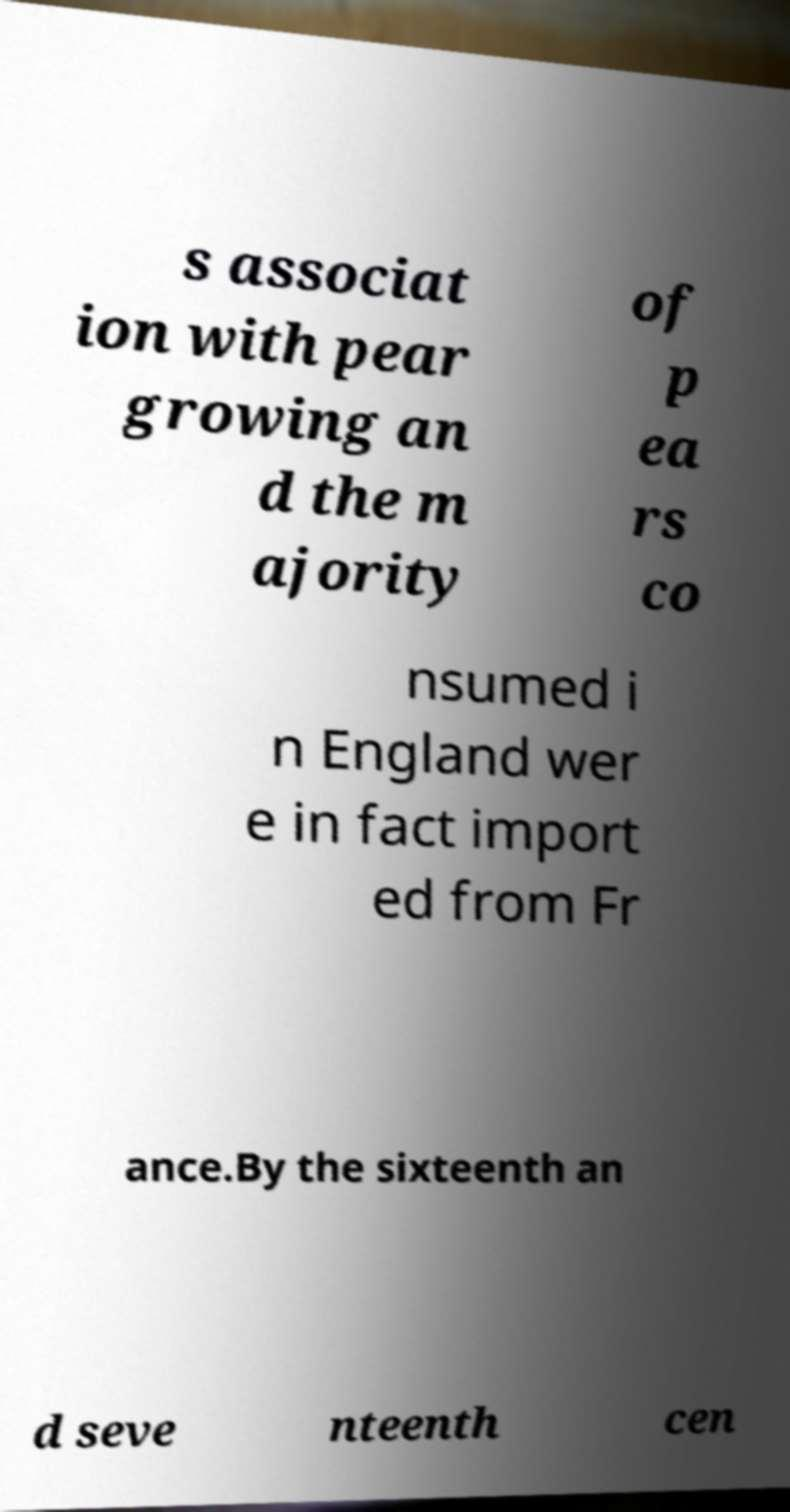Could you assist in decoding the text presented in this image and type it out clearly? s associat ion with pear growing an d the m ajority of p ea rs co nsumed i n England wer e in fact import ed from Fr ance.By the sixteenth an d seve nteenth cen 